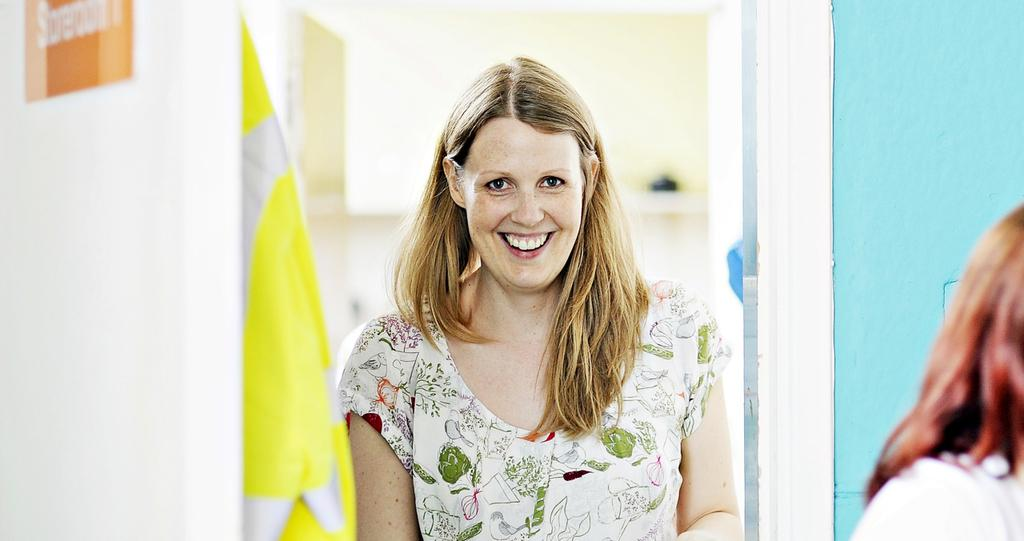Who is present in the image? There is a woman in the image. What is the woman doing? The woman is standing beside a wall and smiling. What is the woman looking at? The woman is looking into a mirror. What color is the wall beside the mirror? The wall beside the mirror is blue. What color is the cloth beside the woman? The cloth beside the woman is yellow. What type of branch is the woman holding in the image? There is no branch present in the image. What is the woman using to plough the field in the image? There is no ploughing activity or field present in the image. 